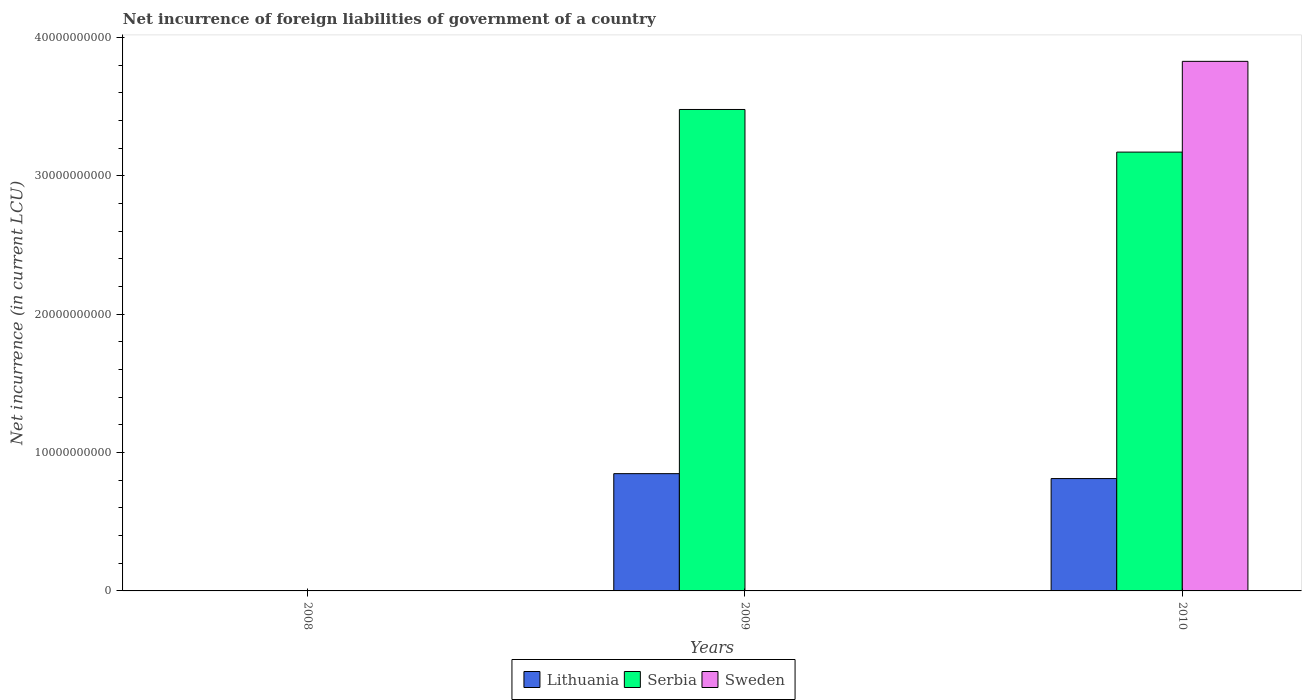How many different coloured bars are there?
Offer a terse response. 3. Are the number of bars per tick equal to the number of legend labels?
Ensure brevity in your answer.  No. What is the label of the 3rd group of bars from the left?
Ensure brevity in your answer.  2010. In how many cases, is the number of bars for a given year not equal to the number of legend labels?
Provide a succinct answer. 2. What is the net incurrence of foreign liabilities in Serbia in 2010?
Keep it short and to the point. 3.17e+1. Across all years, what is the maximum net incurrence of foreign liabilities in Lithuania?
Your answer should be very brief. 8.48e+09. Across all years, what is the minimum net incurrence of foreign liabilities in Serbia?
Offer a very short reply. 0. In which year was the net incurrence of foreign liabilities in Serbia maximum?
Offer a terse response. 2009. What is the total net incurrence of foreign liabilities in Lithuania in the graph?
Offer a very short reply. 1.66e+1. What is the difference between the net incurrence of foreign liabilities in Lithuania in 2009 and that in 2010?
Your answer should be very brief. 3.56e+08. What is the difference between the net incurrence of foreign liabilities in Serbia in 2008 and the net incurrence of foreign liabilities in Sweden in 2010?
Your answer should be very brief. -3.83e+1. What is the average net incurrence of foreign liabilities in Sweden per year?
Keep it short and to the point. 1.28e+1. In the year 2010, what is the difference between the net incurrence of foreign liabilities in Serbia and net incurrence of foreign liabilities in Lithuania?
Offer a terse response. 2.36e+1. In how many years, is the net incurrence of foreign liabilities in Sweden greater than 22000000000 LCU?
Keep it short and to the point. 1. What is the difference between the highest and the lowest net incurrence of foreign liabilities in Serbia?
Offer a very short reply. 3.48e+1. In how many years, is the net incurrence of foreign liabilities in Lithuania greater than the average net incurrence of foreign liabilities in Lithuania taken over all years?
Provide a succinct answer. 2. Is the sum of the net incurrence of foreign liabilities in Lithuania in 2009 and 2010 greater than the maximum net incurrence of foreign liabilities in Serbia across all years?
Provide a succinct answer. No. How many bars are there?
Offer a terse response. 5. Does the graph contain any zero values?
Offer a terse response. Yes. Where does the legend appear in the graph?
Your answer should be very brief. Bottom center. What is the title of the graph?
Offer a terse response. Net incurrence of foreign liabilities of government of a country. What is the label or title of the X-axis?
Offer a terse response. Years. What is the label or title of the Y-axis?
Provide a succinct answer. Net incurrence (in current LCU). What is the Net incurrence (in current LCU) of Lithuania in 2008?
Provide a succinct answer. 0. What is the Net incurrence (in current LCU) in Sweden in 2008?
Ensure brevity in your answer.  0. What is the Net incurrence (in current LCU) of Lithuania in 2009?
Give a very brief answer. 8.48e+09. What is the Net incurrence (in current LCU) in Serbia in 2009?
Provide a short and direct response. 3.48e+1. What is the Net incurrence (in current LCU) of Sweden in 2009?
Make the answer very short. 0. What is the Net incurrence (in current LCU) in Lithuania in 2010?
Provide a succinct answer. 8.12e+09. What is the Net incurrence (in current LCU) of Serbia in 2010?
Your answer should be compact. 3.17e+1. What is the Net incurrence (in current LCU) in Sweden in 2010?
Make the answer very short. 3.83e+1. Across all years, what is the maximum Net incurrence (in current LCU) in Lithuania?
Provide a short and direct response. 8.48e+09. Across all years, what is the maximum Net incurrence (in current LCU) of Serbia?
Your answer should be very brief. 3.48e+1. Across all years, what is the maximum Net incurrence (in current LCU) in Sweden?
Your response must be concise. 3.83e+1. Across all years, what is the minimum Net incurrence (in current LCU) in Lithuania?
Keep it short and to the point. 0. What is the total Net incurrence (in current LCU) of Lithuania in the graph?
Your answer should be compact. 1.66e+1. What is the total Net incurrence (in current LCU) in Serbia in the graph?
Your answer should be very brief. 6.65e+1. What is the total Net incurrence (in current LCU) of Sweden in the graph?
Keep it short and to the point. 3.83e+1. What is the difference between the Net incurrence (in current LCU) in Lithuania in 2009 and that in 2010?
Your answer should be very brief. 3.56e+08. What is the difference between the Net incurrence (in current LCU) of Serbia in 2009 and that in 2010?
Provide a short and direct response. 3.08e+09. What is the difference between the Net incurrence (in current LCU) of Lithuania in 2009 and the Net incurrence (in current LCU) of Serbia in 2010?
Your response must be concise. -2.32e+1. What is the difference between the Net incurrence (in current LCU) of Lithuania in 2009 and the Net incurrence (in current LCU) of Sweden in 2010?
Your answer should be compact. -2.98e+1. What is the difference between the Net incurrence (in current LCU) of Serbia in 2009 and the Net incurrence (in current LCU) of Sweden in 2010?
Provide a short and direct response. -3.48e+09. What is the average Net incurrence (in current LCU) of Lithuania per year?
Give a very brief answer. 5.53e+09. What is the average Net incurrence (in current LCU) in Serbia per year?
Provide a succinct answer. 2.22e+1. What is the average Net incurrence (in current LCU) in Sweden per year?
Ensure brevity in your answer.  1.28e+1. In the year 2009, what is the difference between the Net incurrence (in current LCU) in Lithuania and Net incurrence (in current LCU) in Serbia?
Provide a short and direct response. -2.63e+1. In the year 2010, what is the difference between the Net incurrence (in current LCU) of Lithuania and Net incurrence (in current LCU) of Serbia?
Your response must be concise. -2.36e+1. In the year 2010, what is the difference between the Net incurrence (in current LCU) in Lithuania and Net incurrence (in current LCU) in Sweden?
Give a very brief answer. -3.02e+1. In the year 2010, what is the difference between the Net incurrence (in current LCU) of Serbia and Net incurrence (in current LCU) of Sweden?
Keep it short and to the point. -6.56e+09. What is the ratio of the Net incurrence (in current LCU) of Lithuania in 2009 to that in 2010?
Ensure brevity in your answer.  1.04. What is the ratio of the Net incurrence (in current LCU) of Serbia in 2009 to that in 2010?
Offer a terse response. 1.1. What is the difference between the highest and the lowest Net incurrence (in current LCU) in Lithuania?
Make the answer very short. 8.48e+09. What is the difference between the highest and the lowest Net incurrence (in current LCU) in Serbia?
Your answer should be compact. 3.48e+1. What is the difference between the highest and the lowest Net incurrence (in current LCU) of Sweden?
Offer a very short reply. 3.83e+1. 